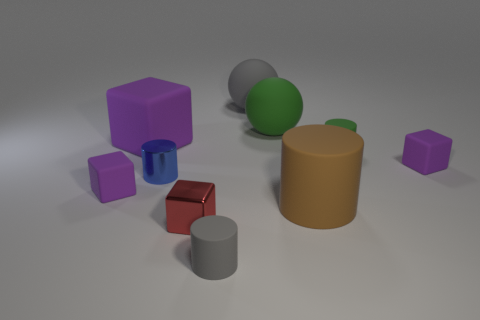Subtract all small cylinders. How many cylinders are left? 1 Subtract all green spheres. How many spheres are left? 1 Subtract all blocks. How many objects are left? 6 Add 2 cylinders. How many cylinders are left? 6 Add 3 small purple objects. How many small purple objects exist? 5 Subtract 0 brown balls. How many objects are left? 10 Subtract 3 blocks. How many blocks are left? 1 Subtract all yellow blocks. Subtract all red cylinders. How many blocks are left? 4 Subtract all brown cylinders. How many green balls are left? 1 Subtract all tiny red balls. Subtract all purple rubber objects. How many objects are left? 7 